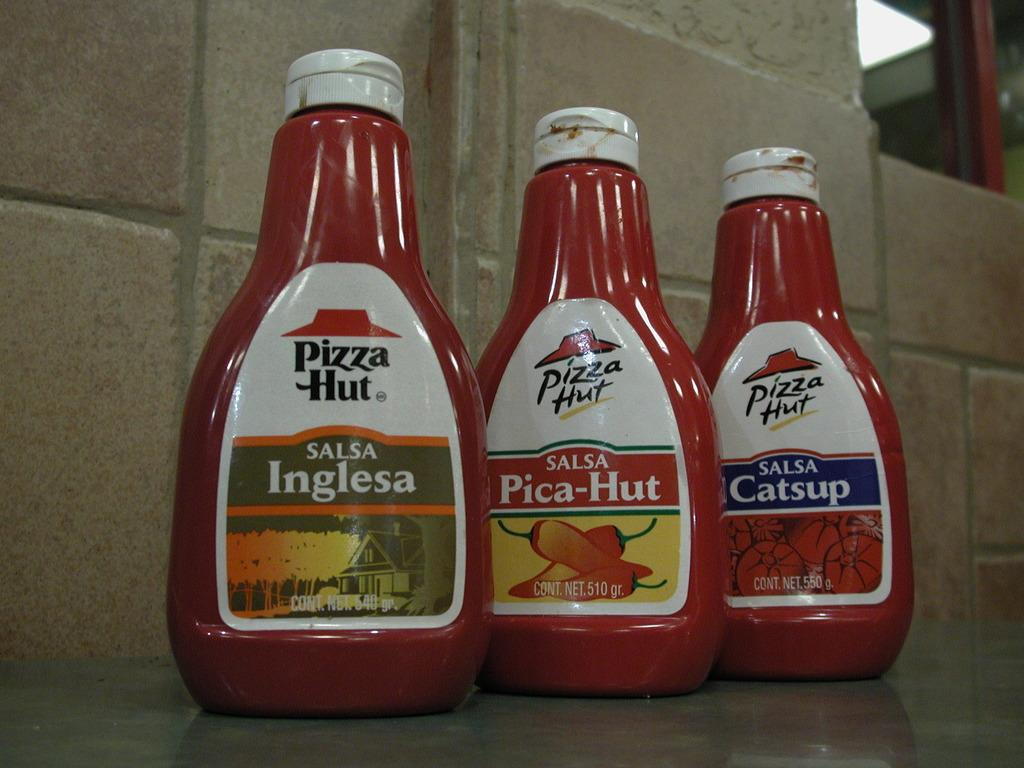<image>
Give a short and clear explanation of the subsequent image. the word Catsup is on the red bottle 